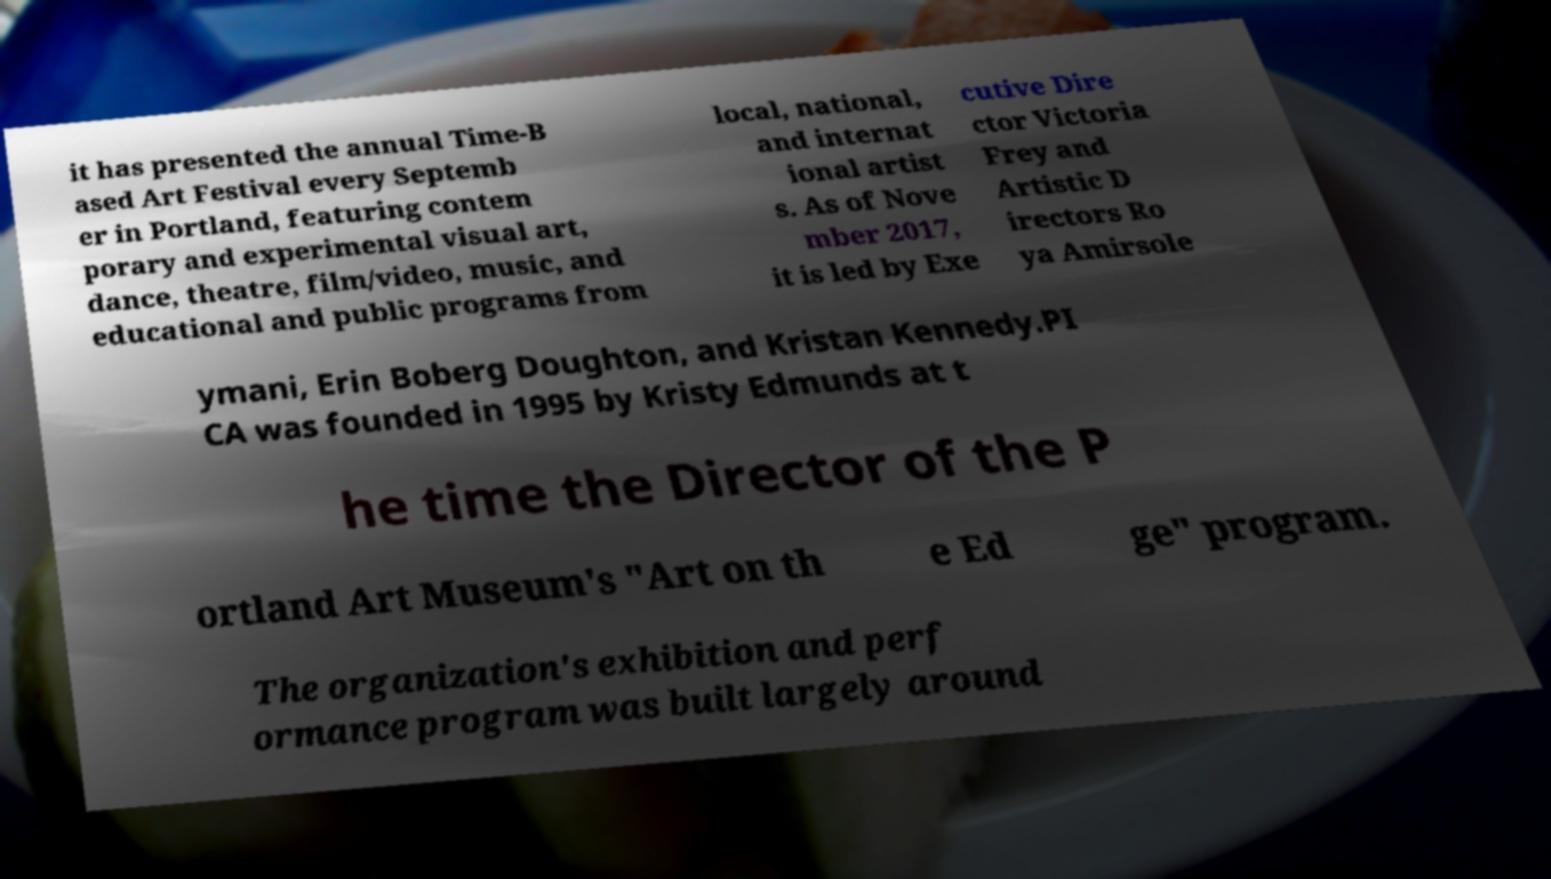Please identify and transcribe the text found in this image. it has presented the annual Time-B ased Art Festival every Septemb er in Portland, featuring contem porary and experimental visual art, dance, theatre, film/video, music, and educational and public programs from local, national, and internat ional artist s. As of Nove mber 2017, it is led by Exe cutive Dire ctor Victoria Frey and Artistic D irectors Ro ya Amirsole ymani, Erin Boberg Doughton, and Kristan Kennedy.PI CA was founded in 1995 by Kristy Edmunds at t he time the Director of the P ortland Art Museum's "Art on th e Ed ge" program. The organization's exhibition and perf ormance program was built largely around 